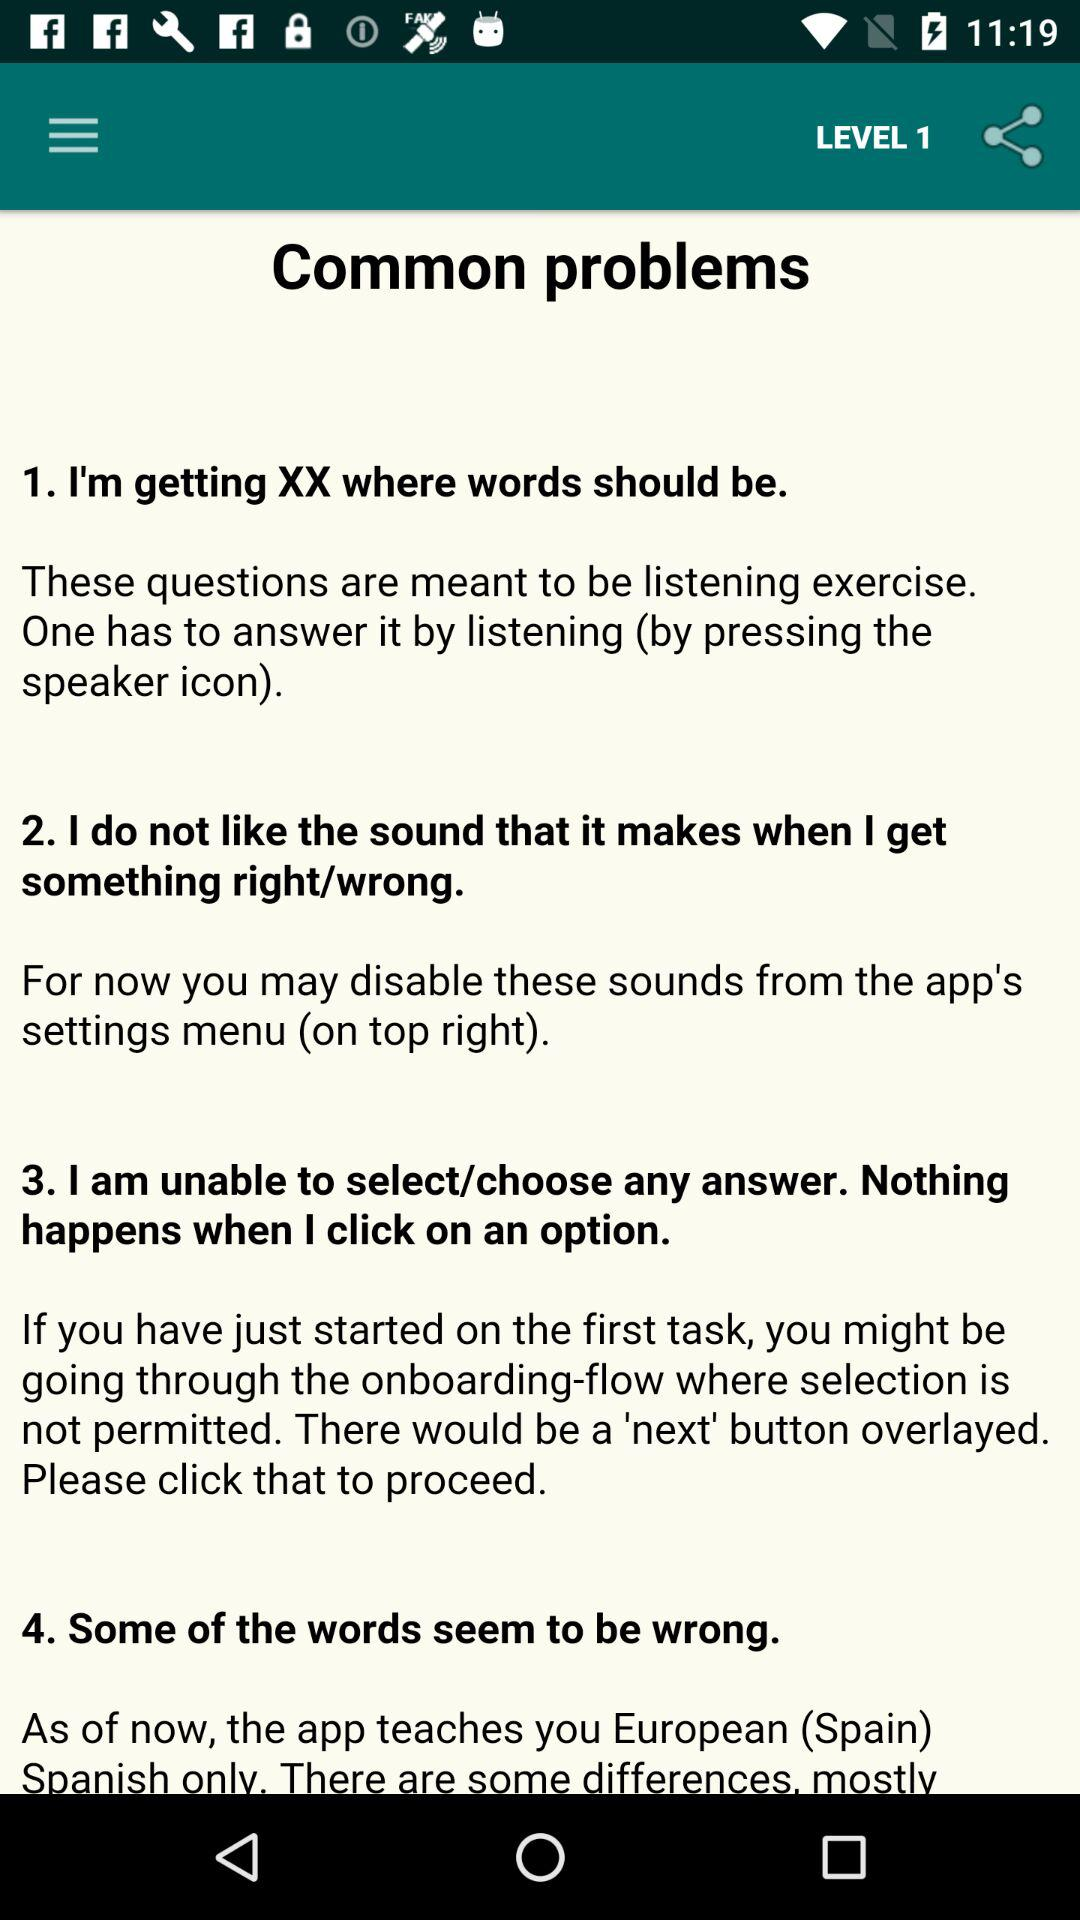What level number is shown on the screen? The shown level number is 1. 